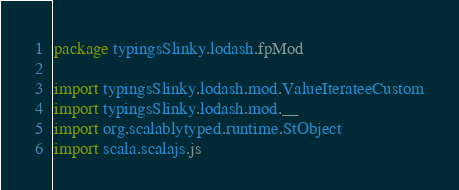<code> <loc_0><loc_0><loc_500><loc_500><_Scala_>package typingsSlinky.lodash.fpMod

import typingsSlinky.lodash.mod.ValueIterateeCustom
import typingsSlinky.lodash.mod.__
import org.scalablytyped.runtime.StObject
import scala.scalajs.js</code> 